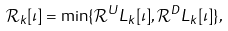Convert formula to latex. <formula><loc_0><loc_0><loc_500><loc_500>\mathcal { R } _ { k } [ \iota ] = \min \{ \mathcal { R } ^ { U } L _ { k } [ \iota ] , \mathcal { R } ^ { D } L _ { k } [ \iota ] \} ,</formula> 